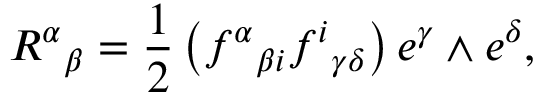<formula> <loc_0><loc_0><loc_500><loc_500>{ R ^ { \alpha } } _ { \beta } = { \frac { 1 } { 2 } } \left ( { f ^ { \alpha } } _ { \beta i } { f ^ { i } } _ { \gamma \delta } \right ) e ^ { \gamma } \wedge e ^ { \delta } ,</formula> 